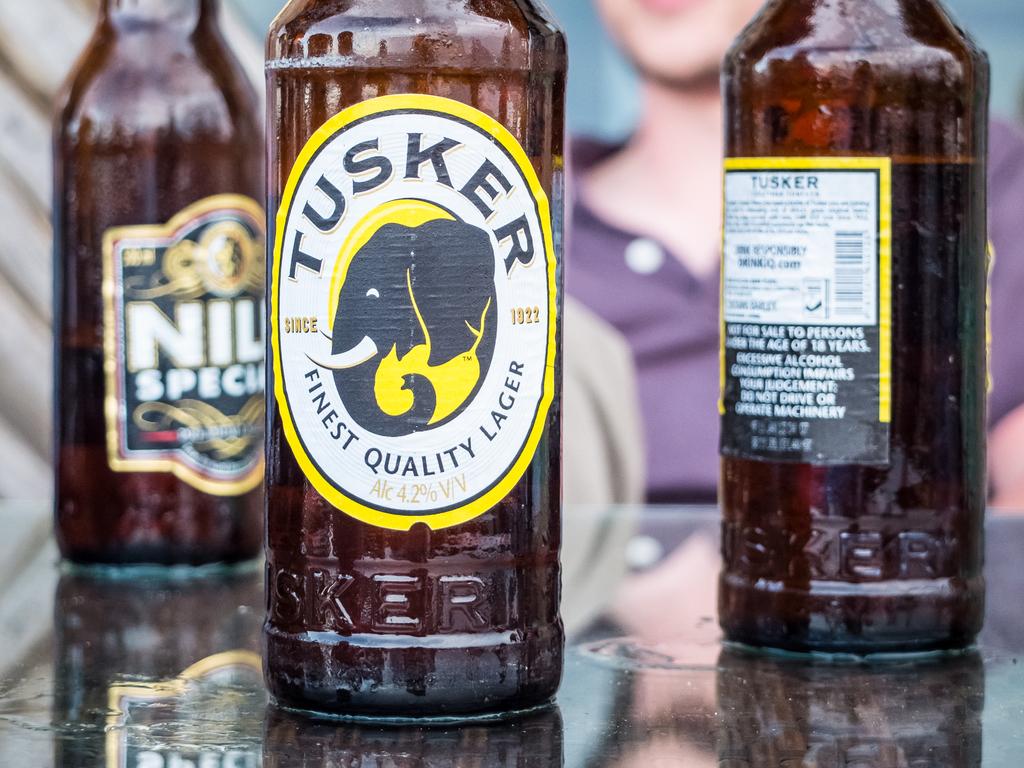What is the name of this beer?
Keep it short and to the point. Tusker. What is the alcohol content of the center beer?
Offer a very short reply. 4.2%. 